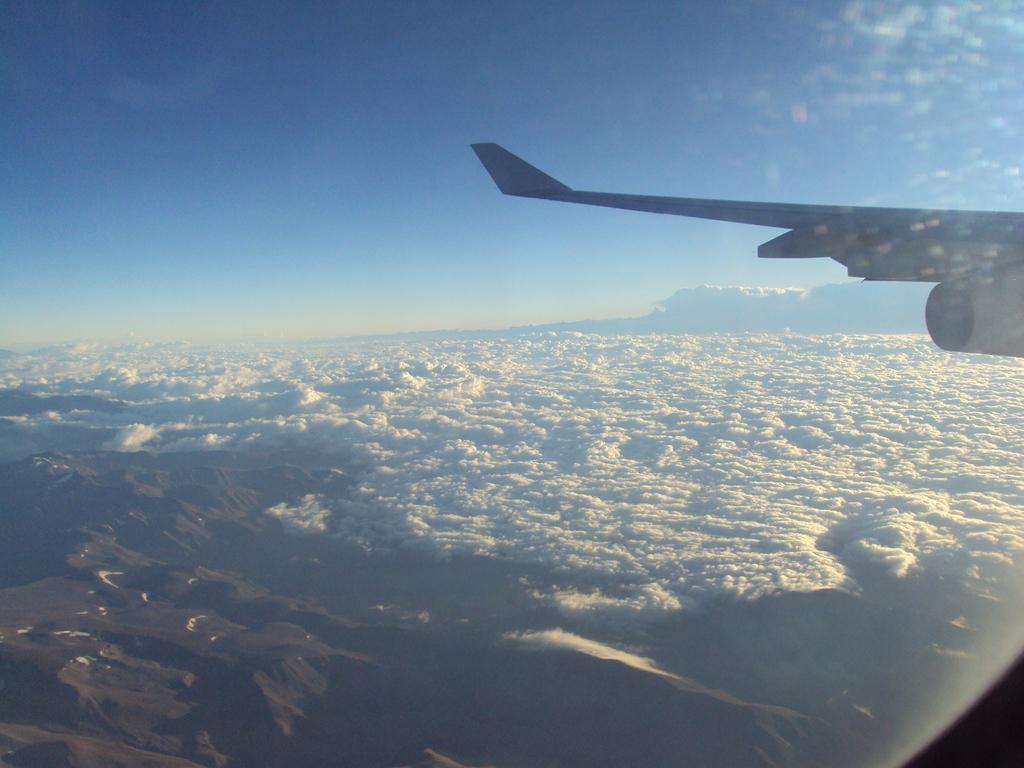In one or two sentences, can you explain what this image depicts? In this image we can see the aerial photo which was taken from an aircraft and we can see the mountains and clouds and we can see the sky. On the right side of the image we can see an airplane wing. 